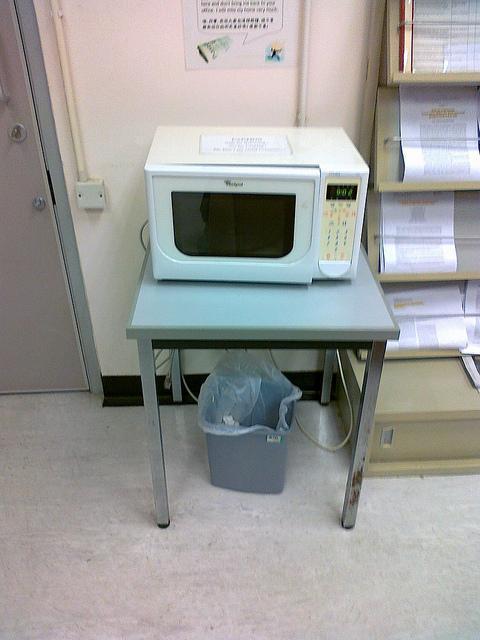How many people are wearing a yellow shirt in the image?
Give a very brief answer. 0. 